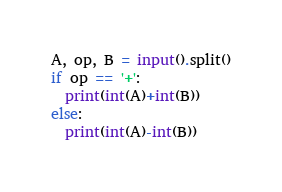Convert code to text. <code><loc_0><loc_0><loc_500><loc_500><_Python_>A, op, B = input().split()
if op == '+':
  print(int(A)+int(B))
else:
  print(int(A)-int(B))</code> 